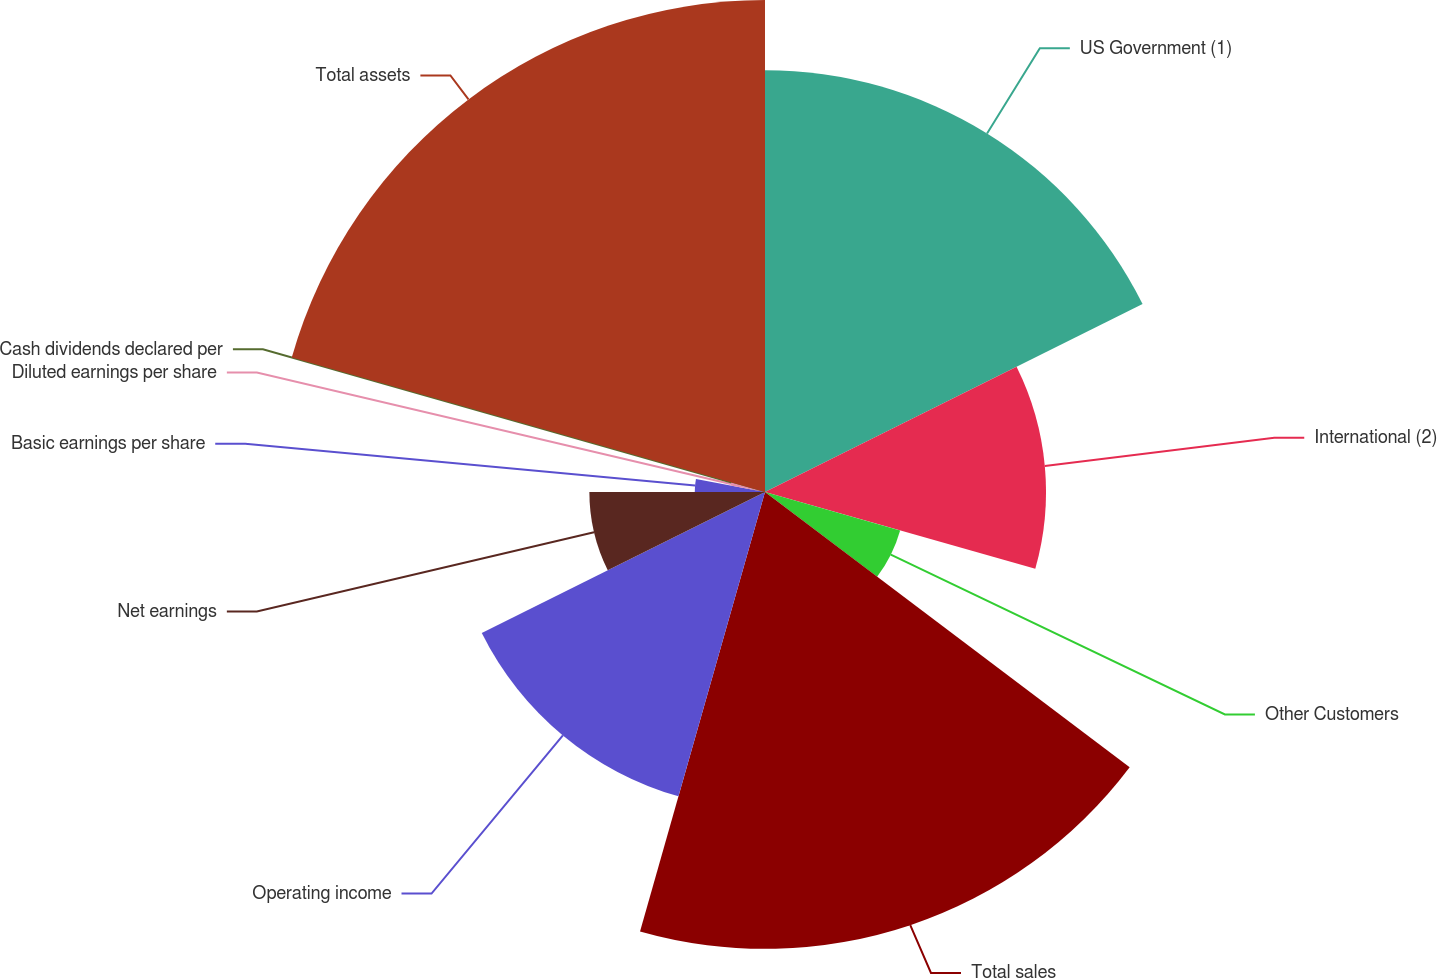Convert chart. <chart><loc_0><loc_0><loc_500><loc_500><pie_chart><fcel>US Government (1)<fcel>International (2)<fcel>Other Customers<fcel>Total sales<fcel>Operating income<fcel>Net earnings<fcel>Basic earnings per share<fcel>Diluted earnings per share<fcel>Cash dividends declared per<fcel>Total assets<nl><fcel>17.65%<fcel>11.76%<fcel>5.88%<fcel>19.12%<fcel>13.24%<fcel>7.35%<fcel>2.94%<fcel>1.47%<fcel>0.0%<fcel>20.59%<nl></chart> 